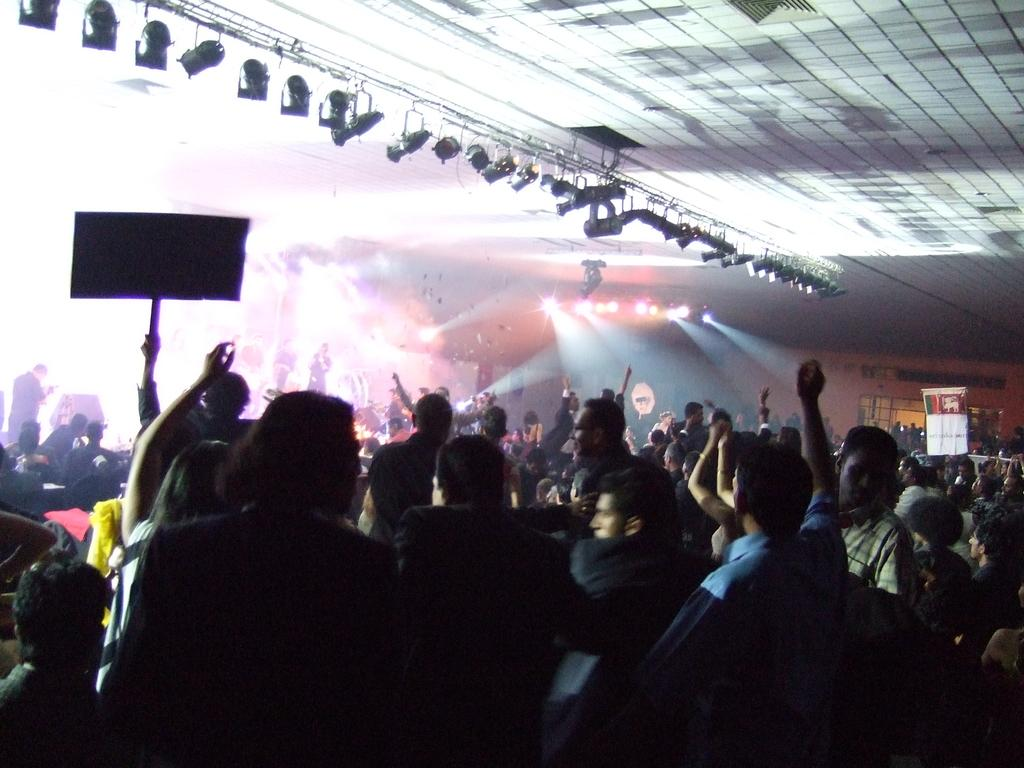What can be seen in the image involving people? There are people standing in the image. What objects are visible in the image besides people? There are boards and lights visible in the image. What type of paper is being pinned to the board in the image? There is no paper or pinning action visible in the image. What is the view like from the perspective of the people in the image? The provided facts do not give any information about the view or perspective of the people in the image. 